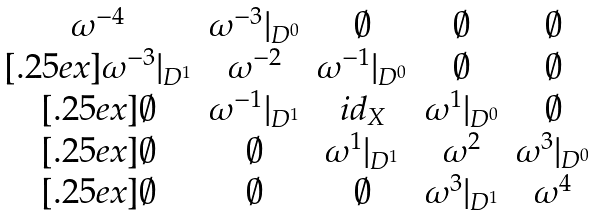<formula> <loc_0><loc_0><loc_500><loc_500>\begin{matrix} \omega ^ { - 4 } & \omega ^ { - 3 } | _ { D ^ { 0 } } & \emptyset & \emptyset & \emptyset \\ [ . 2 5 e x ] \omega ^ { - 3 } | _ { D ^ { 1 } } & \omega ^ { - 2 } & \omega ^ { - 1 } | _ { D ^ { 0 } } & \emptyset & \emptyset \\ [ . 2 5 e x ] \emptyset & \omega ^ { - 1 } | _ { D ^ { 1 } } & i d _ { X } & \omega ^ { 1 } | _ { D ^ { 0 } } & \emptyset \\ [ . 2 5 e x ] \emptyset & \emptyset & \omega ^ { 1 } | _ { D ^ { 1 } } & \omega ^ { 2 } & \omega ^ { 3 } | _ { D ^ { 0 } } \\ [ . 2 5 e x ] \emptyset & \emptyset & \emptyset & \omega ^ { 3 } | _ { D ^ { 1 } } & \omega ^ { 4 } \end{matrix}</formula> 